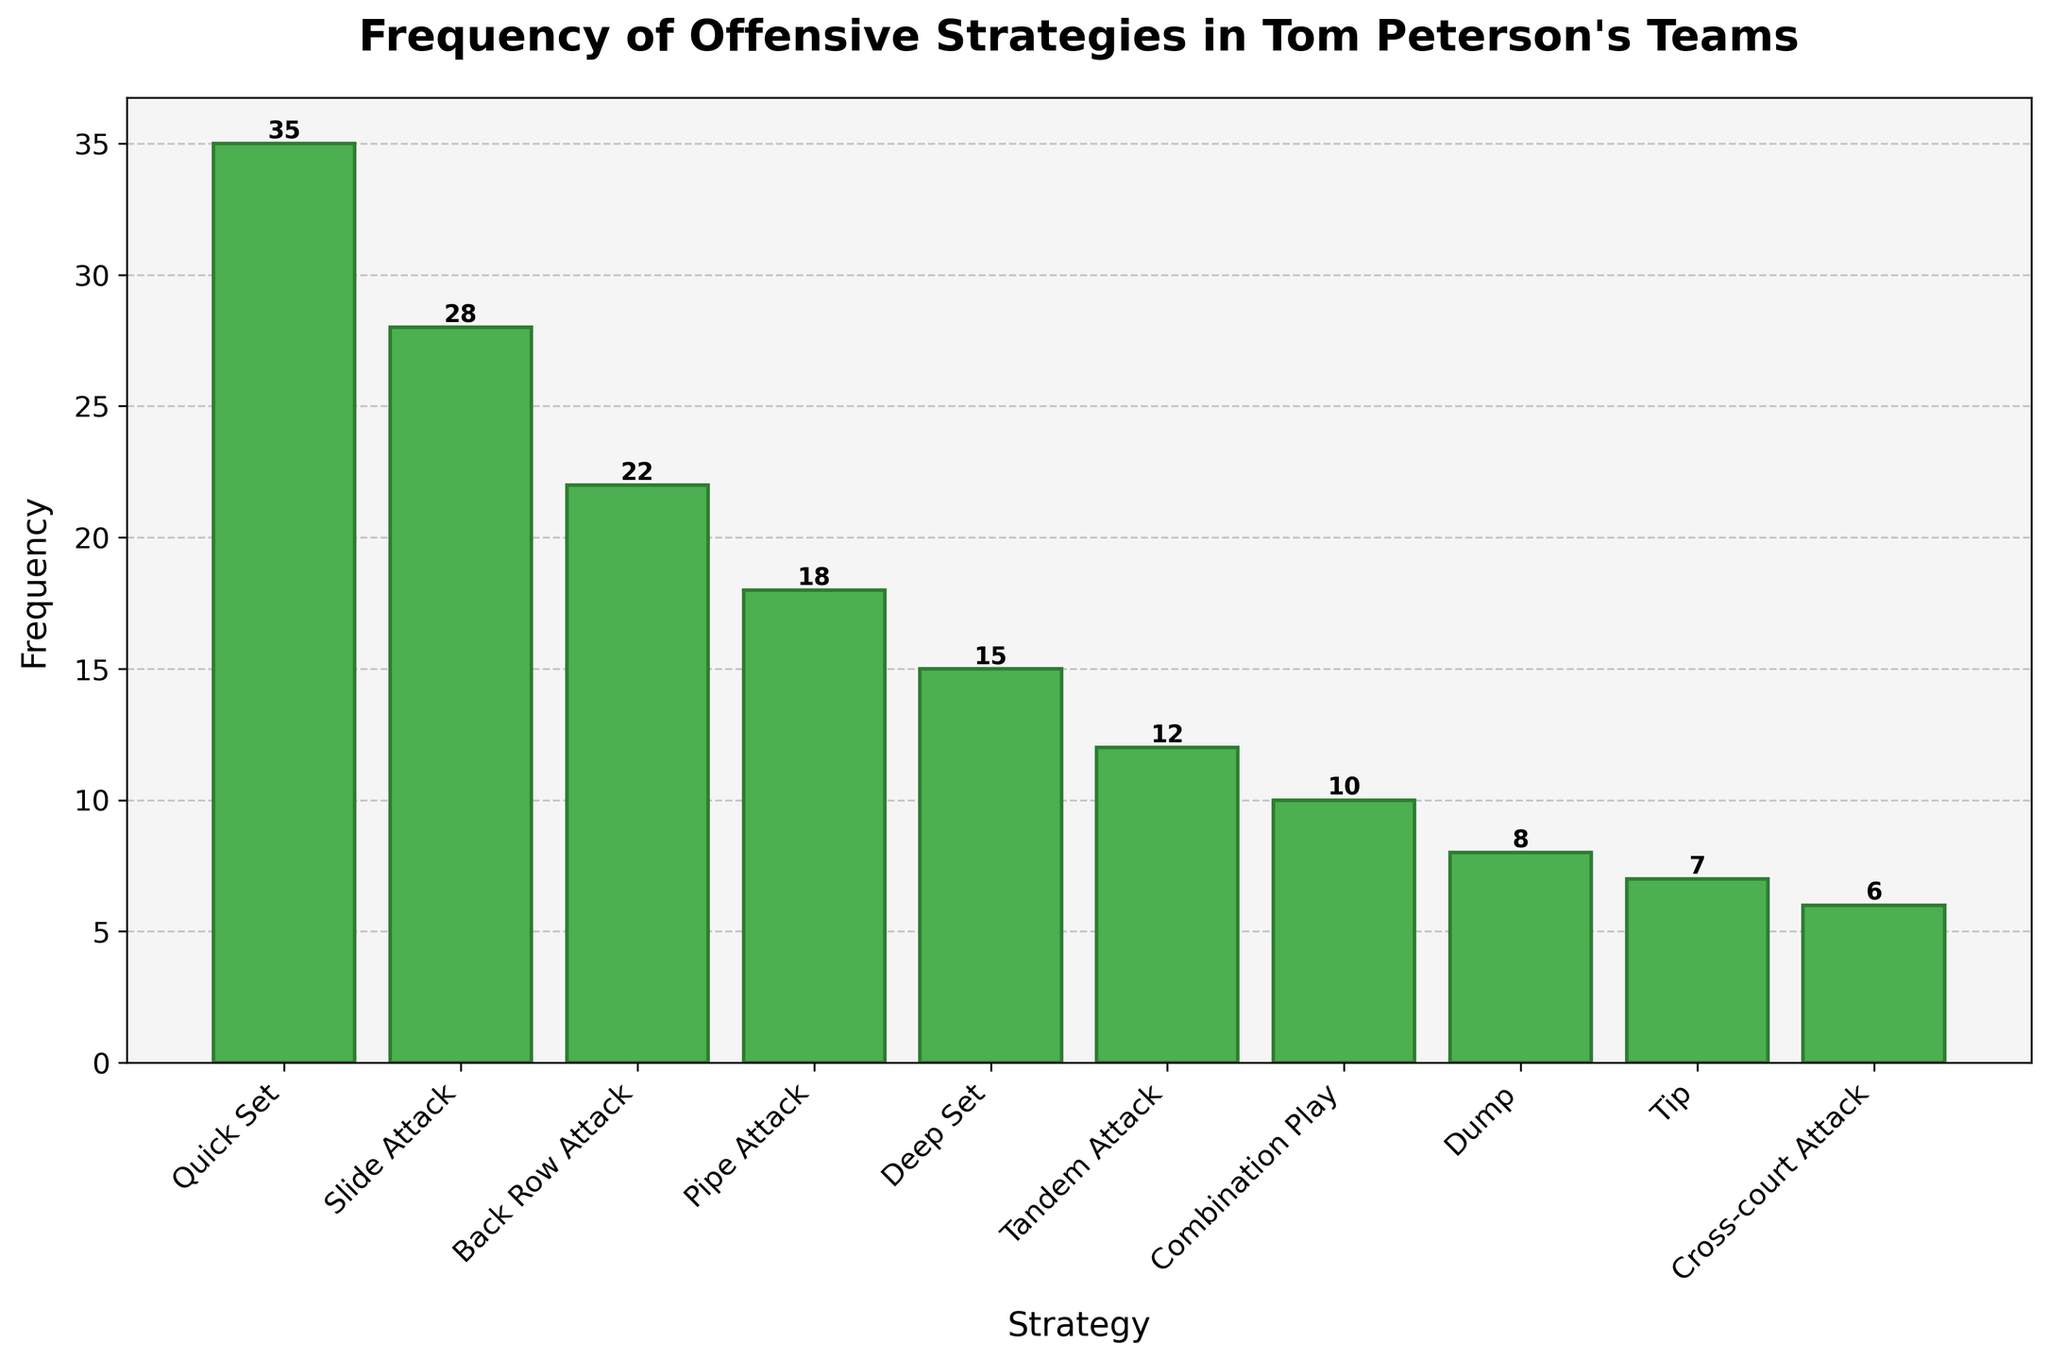Which offensive strategy is the most frequently employed by Tom Peterson's teams? The bar representing the "Quick Set" strategy is the tallest among all the bars, indicating that it has the highest frequency.
Answer: Quick Set What is the frequency difference between the "Quick Set" and "Slide Attack"? The height of the "Quick Set" bar is 35 and the "Slide Attack" bar is 28. Subtracting these values gives 35 - 28 = 7.
Answer: 7 Which strategy has the lowest frequency? The bar representing the "Cross-court Attack" strategy has the shortest height, indicating it has the lowest frequency.
Answer: Cross-court Attack What is the total frequency of the "Back Row Attack", "Pipe Attack", and "Deep Set" strategies combined? Summing up the frequencies for "Back Row Attack" (22), "Pipe Attack" (18), and "Deep Set" (15) gives 22 + 18 + 15 = 55.
Answer: 55 How many strategies have a frequency greater than 20? Counting the bars that have a frequency higher than 20, we find "Quick Set" (35), "Slide Attack" (28), and "Back Row Attack" (22), which makes 3 strategies.
Answer: 3 Is the frequency of "Tip" higher or lower than "Dump"? The height of the "Tip" bar is 7, while the height of the "Dump" bar is 8, so "Tip" is lower than "Dump".
Answer: Lower What is the average frequency of strategies employed by Tom Peterson's teams? Summing all the frequencies: 35 + 28 + 22 + 18 + 15 + 12 + 10 + 8 + 7 + 6 = 161. Dividing by the number of strategies (10), we get 161 / 10 = 16.1.
Answer: 16.1 How much taller is the "Quick Set" bar compared to the "Pipe Attack" bar? The "Quick Set" bar's height is 35 and the "Pipe Attack" bar's height is 18. The difference is 35 - 18 = 17.
Answer: 17 Which strategies fall within the frequency range of 10 to 20 inclusive? The bars representing "Pipe Attack" (18), "Deep Set" (15), and "Tandem Attack" (12) fall within this range.
Answer: Pipe Attack, Deep Set, Tandem Attack 